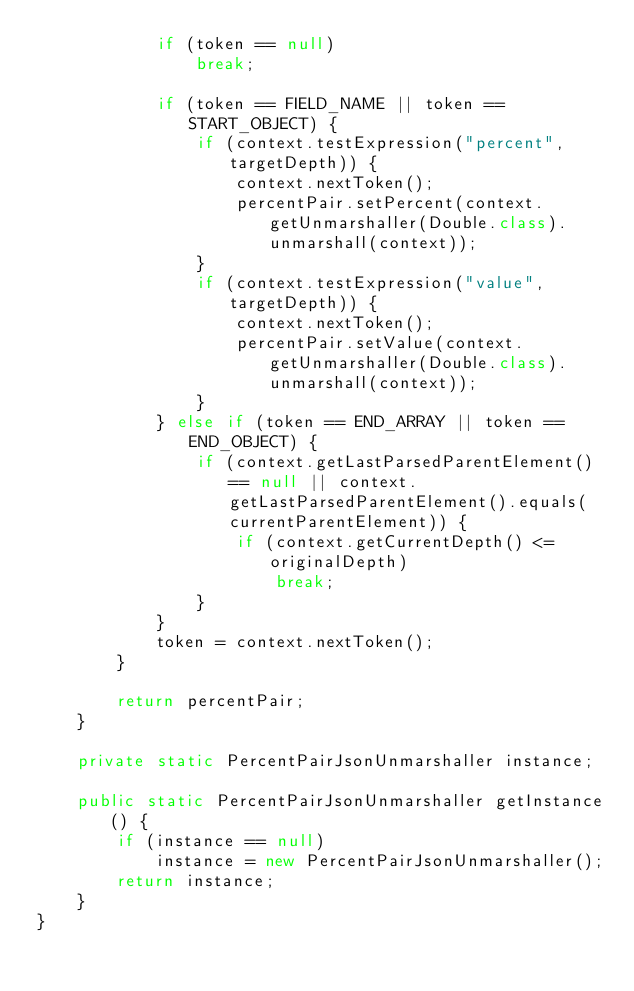Convert code to text. <code><loc_0><loc_0><loc_500><loc_500><_Java_>            if (token == null)
                break;

            if (token == FIELD_NAME || token == START_OBJECT) {
                if (context.testExpression("percent", targetDepth)) {
                    context.nextToken();
                    percentPair.setPercent(context.getUnmarshaller(Double.class).unmarshall(context));
                }
                if (context.testExpression("value", targetDepth)) {
                    context.nextToken();
                    percentPair.setValue(context.getUnmarshaller(Double.class).unmarshall(context));
                }
            } else if (token == END_ARRAY || token == END_OBJECT) {
                if (context.getLastParsedParentElement() == null || context.getLastParsedParentElement().equals(currentParentElement)) {
                    if (context.getCurrentDepth() <= originalDepth)
                        break;
                }
            }
            token = context.nextToken();
        }

        return percentPair;
    }

    private static PercentPairJsonUnmarshaller instance;

    public static PercentPairJsonUnmarshaller getInstance() {
        if (instance == null)
            instance = new PercentPairJsonUnmarshaller();
        return instance;
    }
}
</code> 